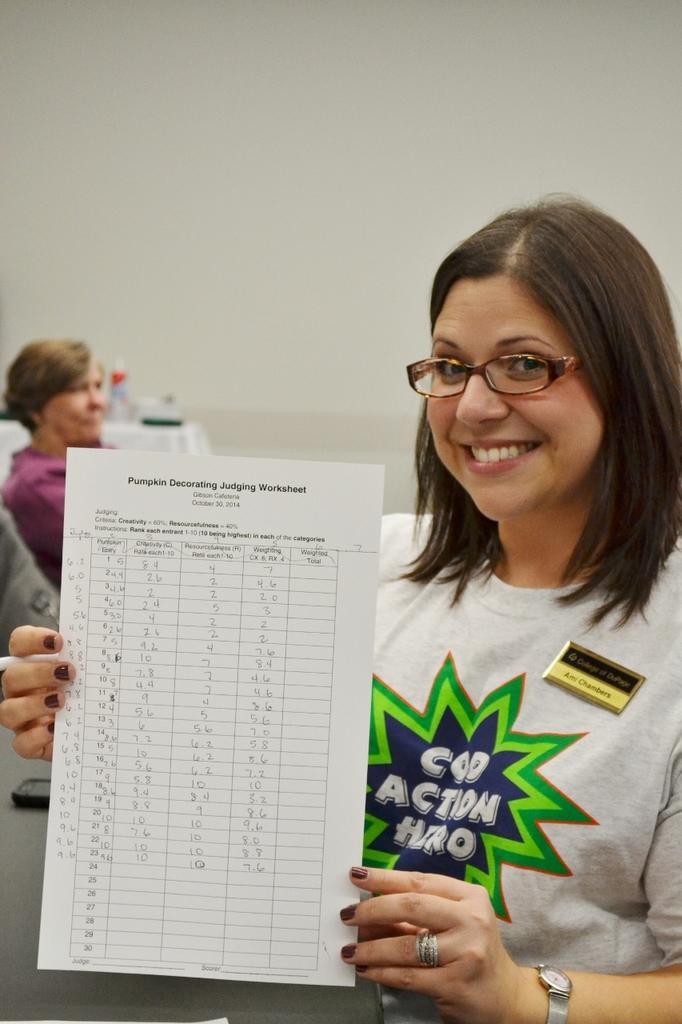Please provide a concise description of this image. In this image I can see a person standing holding a paper which is in white color. The person is wearing white color shirt, background I can see the other person sitting and the wall is in white color. 